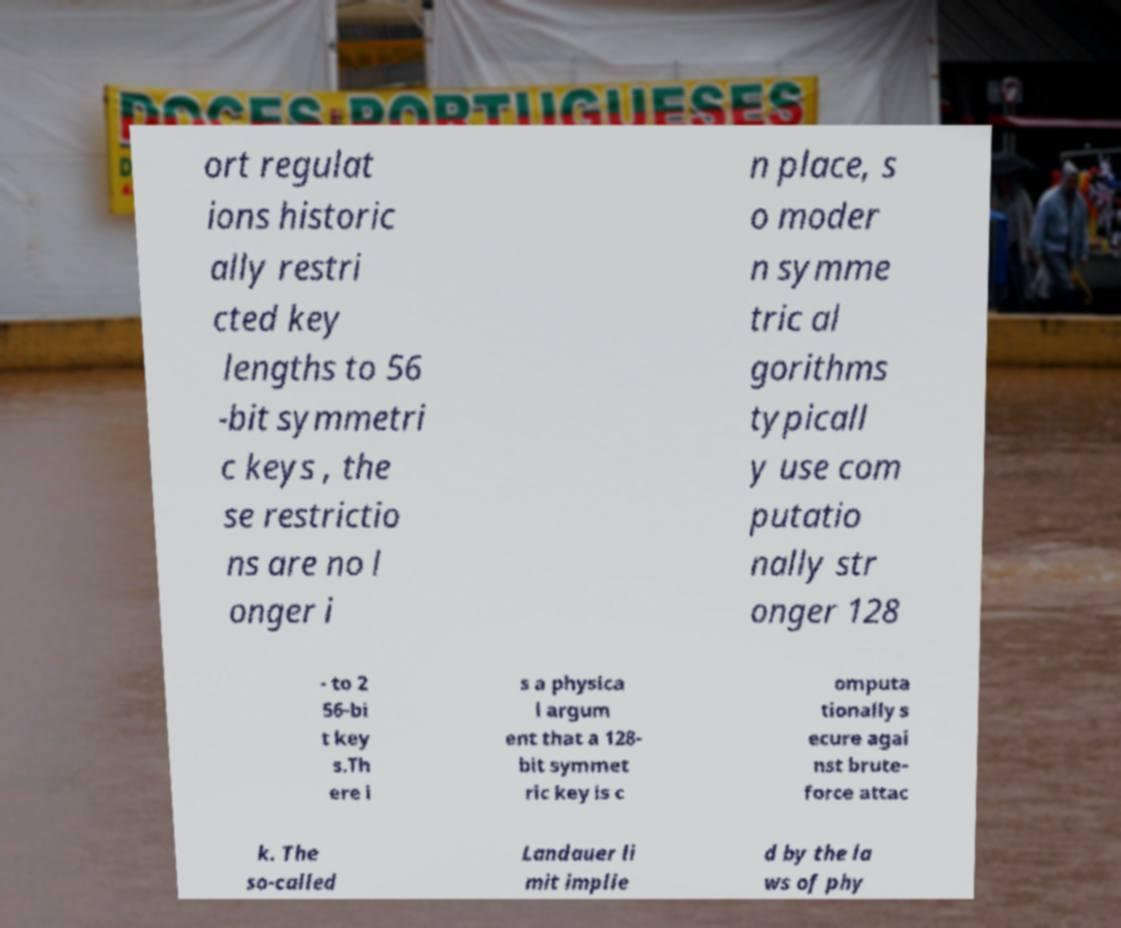Please identify and transcribe the text found in this image. ort regulat ions historic ally restri cted key lengths to 56 -bit symmetri c keys , the se restrictio ns are no l onger i n place, s o moder n symme tric al gorithms typicall y use com putatio nally str onger 128 - to 2 56-bi t key s.Th ere i s a physica l argum ent that a 128- bit symmet ric key is c omputa tionally s ecure agai nst brute- force attac k. The so-called Landauer li mit implie d by the la ws of phy 